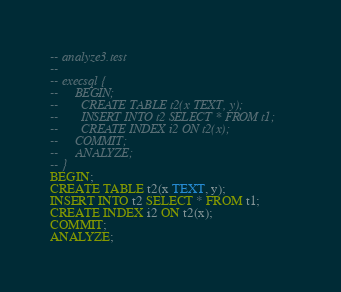<code> <loc_0><loc_0><loc_500><loc_500><_SQL_>-- analyze3.test
-- 
-- execsql {
--     BEGIN;
--       CREATE TABLE t2(x TEXT, y);
--       INSERT INTO t2 SELECT * FROM t1;
--       CREATE INDEX i2 ON t2(x);
--     COMMIT;
--     ANALYZE;
-- }
BEGIN;
CREATE TABLE t2(x TEXT, y);
INSERT INTO t2 SELECT * FROM t1;
CREATE INDEX i2 ON t2(x);
COMMIT;
ANALYZE;</code> 